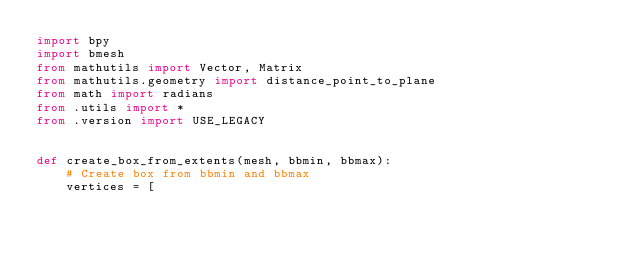<code> <loc_0><loc_0><loc_500><loc_500><_Python_>import bpy
import bmesh
from mathutils import Vector, Matrix
from mathutils.geometry import distance_point_to_plane
from math import radians
from .utils import *
from .version import USE_LEGACY


def create_box_from_extents(mesh, bbmin, bbmax):
    # Create box from bbmin and bbmax
    vertices = [</code> 